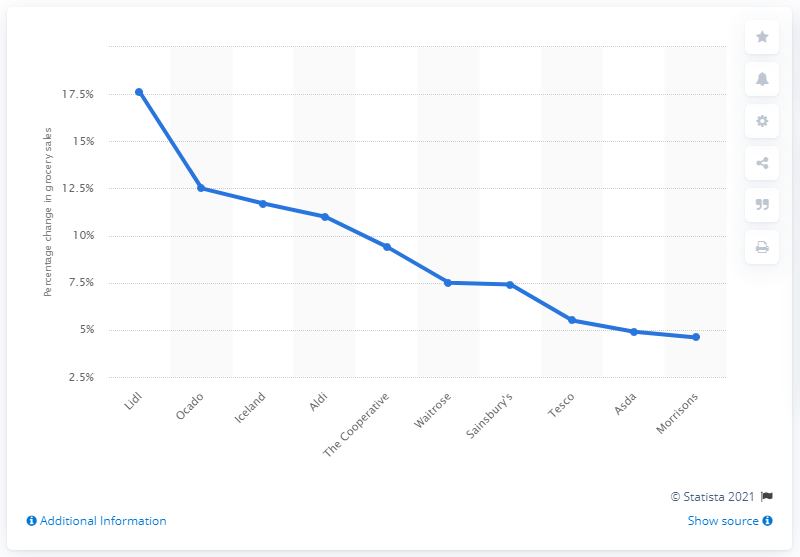Identify some key points in this picture. Sainsbury's saw the largest increase in sales among Teso and Morrison's, along with other supermarkets. Morrisons demonstrated the lowest growth in sales among all supermarkets. 